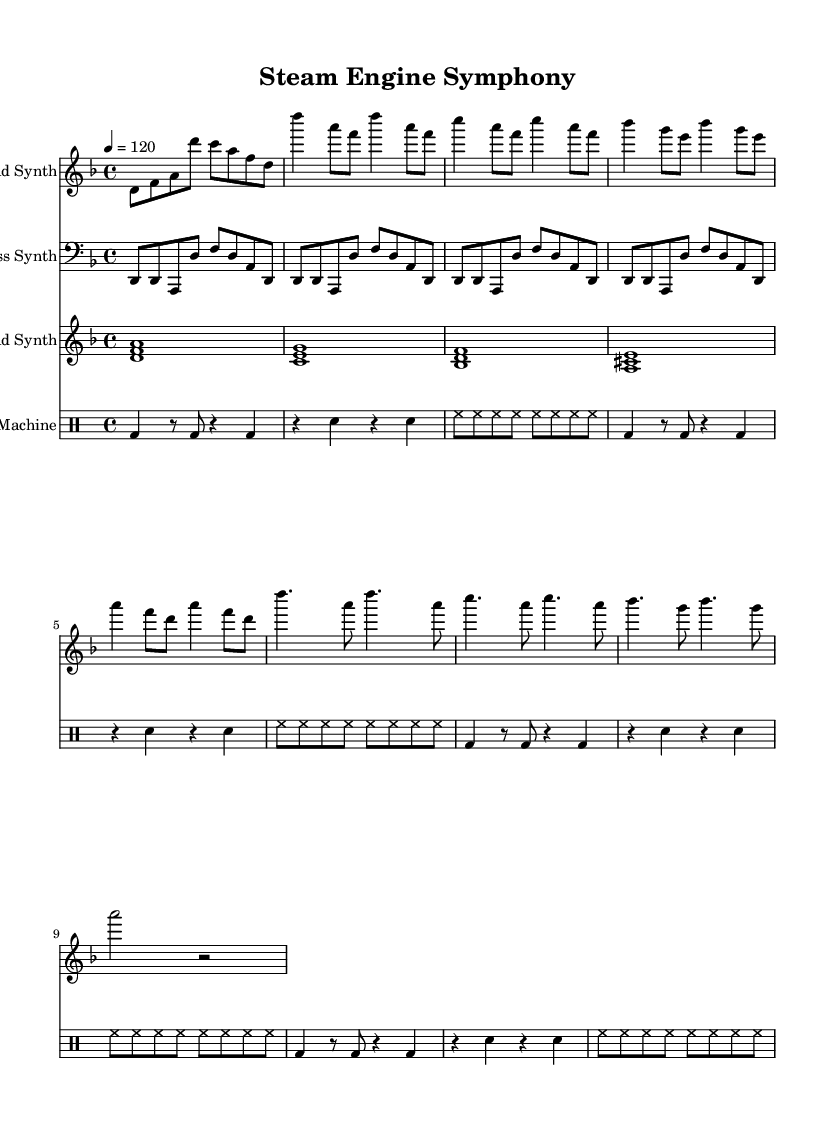What is the key signature of this music? The key signature is D minor, which has one flat (B flat).
Answer: D minor What is the time signature of this music? The time signature is 4/4, indicating four beats per measure.
Answer: 4/4 What is the tempo marking of this piece? The tempo marking indicates a speed of 120 beats per minute.
Answer: 120 How many measures are in the lead synth part? By counting the measures in the lead synth notation, there are a total of 16 measures.
Answer: 16 What is the first note of the bass synth part? The bass synth starts on D in the bass clef, as seen in the first measure.
Answer: D Which instrument plays chords in this arrangement? The pad synth plays sustained chords to complement the other synth parts.
Answer: Pad Synth What rhythmic figure is repeated for the drum machine? The drum machine repeats a pattern featuring kick drum and snare on beats 1 and 3, respectively.
Answer: Kick and snare pattern 